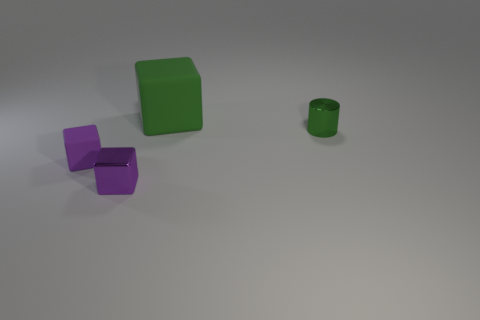Are there an equal number of cylinders on the right side of the big matte object and green shiny things that are to the right of the metallic cylinder?
Your answer should be very brief. No. Is the number of tiny matte things greater than the number of brown rubber objects?
Keep it short and to the point. Yes. How many metal objects are either large brown cubes or small purple objects?
Provide a succinct answer. 1. How many shiny blocks are the same color as the big rubber thing?
Keep it short and to the point. 0. What material is the green object that is in front of the cube behind the matte thing that is in front of the green shiny cylinder?
Provide a succinct answer. Metal. What is the color of the matte block in front of the rubber thing behind the tiny green object?
Ensure brevity in your answer.  Purple. How many big things are green metallic blocks or green matte blocks?
Provide a short and direct response. 1. How many other tiny green cylinders have the same material as the green cylinder?
Make the answer very short. 0. What size is the purple cube that is in front of the small purple rubber thing?
Your response must be concise. Small. There is a rubber thing that is to the left of the rubber cube on the right side of the tiny purple shiny cube; what shape is it?
Give a very brief answer. Cube. 